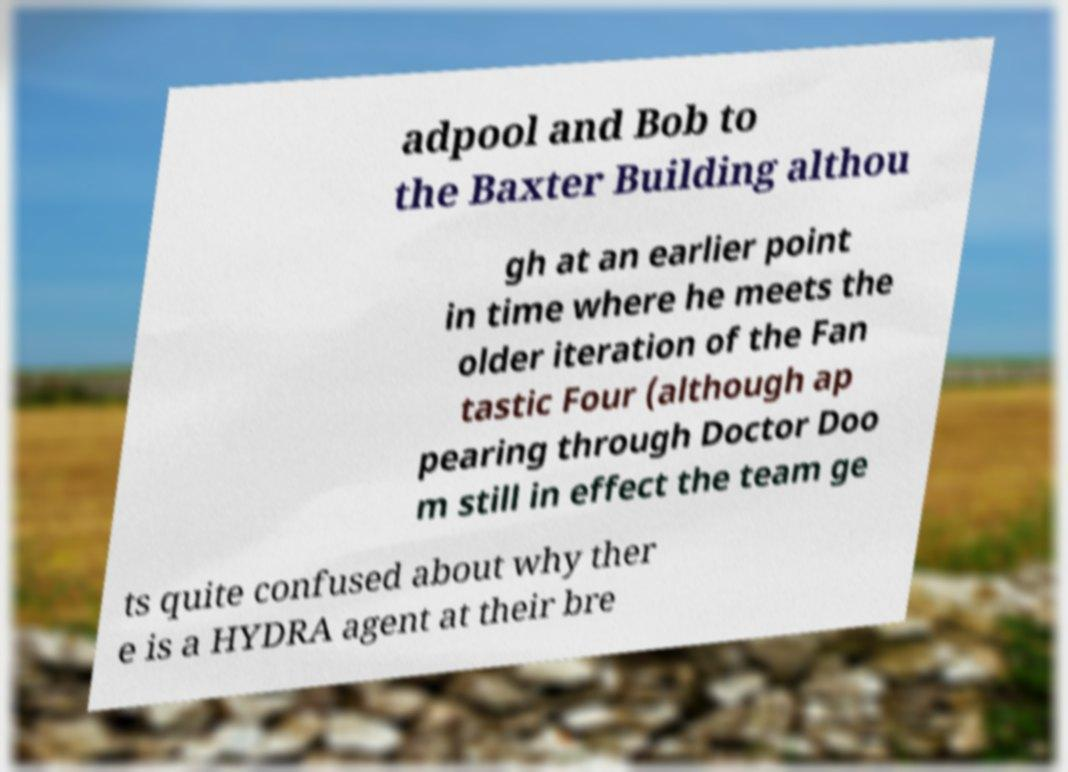Can you read and provide the text displayed in the image?This photo seems to have some interesting text. Can you extract and type it out for me? adpool and Bob to the Baxter Building althou gh at an earlier point in time where he meets the older iteration of the Fan tastic Four (although ap pearing through Doctor Doo m still in effect the team ge ts quite confused about why ther e is a HYDRA agent at their bre 